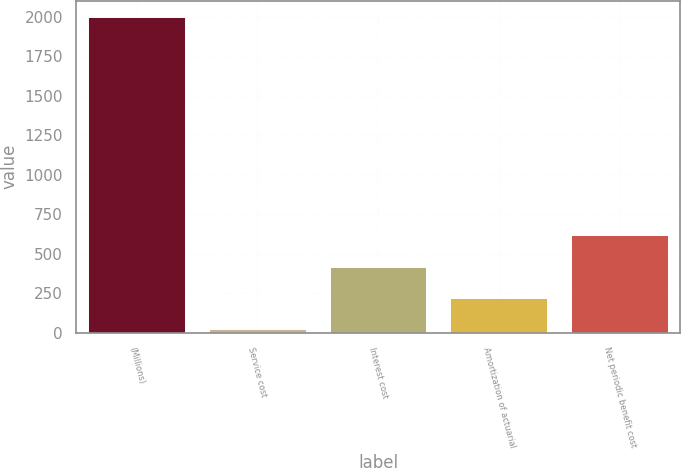<chart> <loc_0><loc_0><loc_500><loc_500><bar_chart><fcel>(Millions)<fcel>Service cost<fcel>Interest cost<fcel>Amortization of actuarial<fcel>Net periodic benefit cost<nl><fcel>2003<fcel>23<fcel>419<fcel>221<fcel>617<nl></chart> 